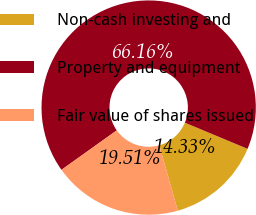Convert chart to OTSL. <chart><loc_0><loc_0><loc_500><loc_500><pie_chart><fcel>Non-cash investing and<fcel>Property and equipment<fcel>Fair value of shares issued<nl><fcel>14.33%<fcel>66.16%<fcel>19.51%<nl></chart> 